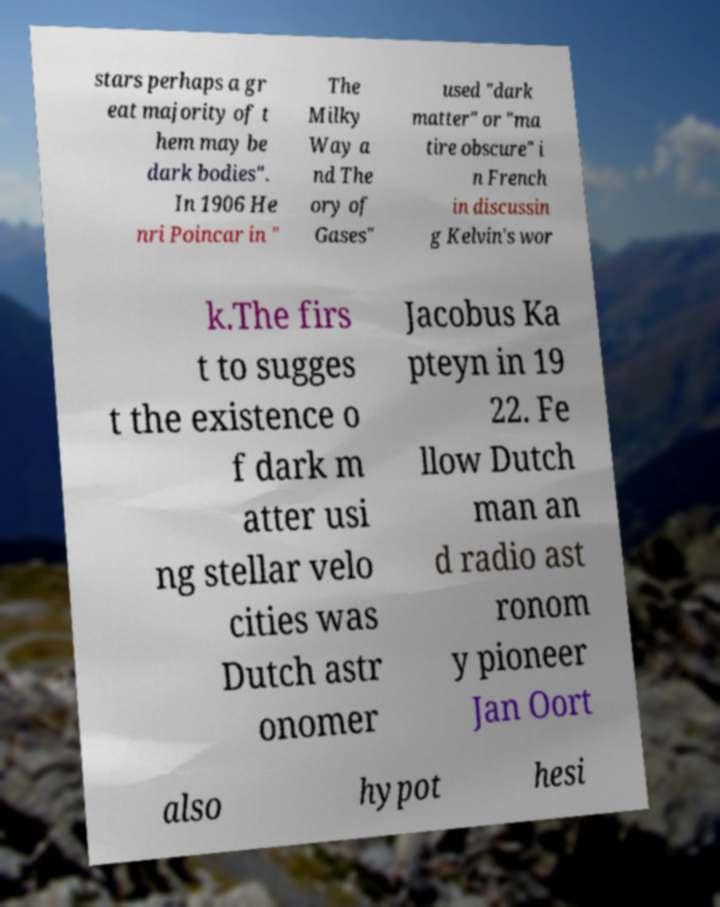Please read and relay the text visible in this image. What does it say? stars perhaps a gr eat majority of t hem may be dark bodies". In 1906 He nri Poincar in " The Milky Way a nd The ory of Gases" used "dark matter" or "ma tire obscure" i n French in discussin g Kelvin's wor k.The firs t to sugges t the existence o f dark m atter usi ng stellar velo cities was Dutch astr onomer Jacobus Ka pteyn in 19 22. Fe llow Dutch man an d radio ast ronom y pioneer Jan Oort also hypot hesi 